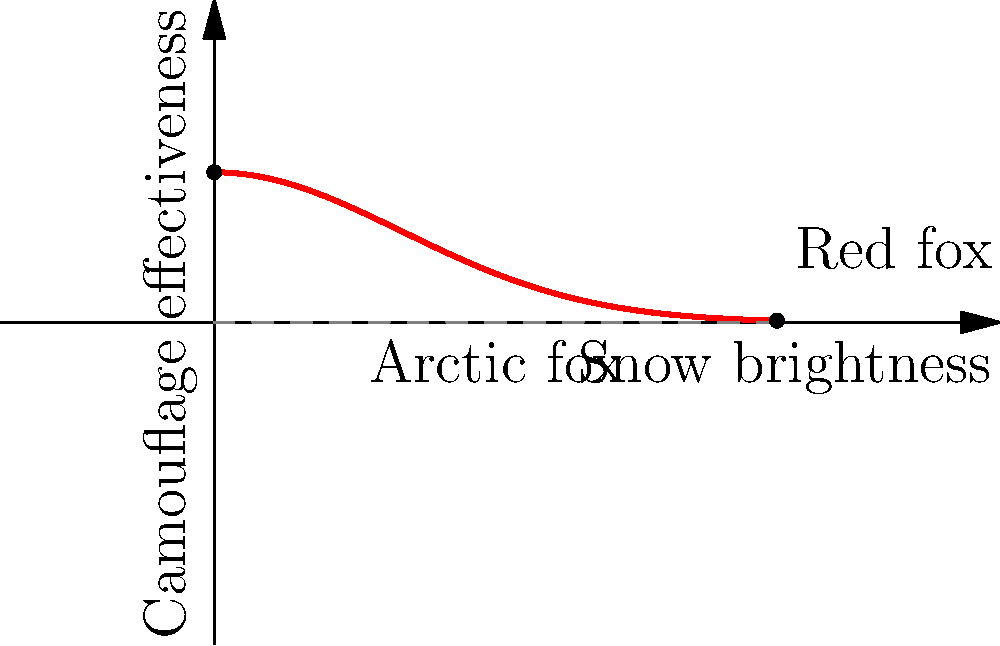Based on the graph showing the camouflage effectiveness of foxes in relation to snow brightness, which type of fox would be easier to spot in extremely bright snow conditions? To answer this question, we need to analyze the graph:

1. The x-axis represents snow brightness, increasing from left to right.
2. The y-axis represents camouflage effectiveness, increasing from bottom to top.
3. The curve shows how camouflage effectiveness changes with snow brightness.
4. At the left side of the graph (low snow brightness), we see "Arctic fox" labeled, indicating high camouflage effectiveness in less bright conditions.
5. At the right side of the graph (high snow brightness), we see "Red fox" labeled, indicating lower camouflage effectiveness in brighter conditions.
6. As snow brightness increases (moving right on the x-axis), the camouflage effectiveness decreases (the curve slopes downward).
7. In extremely bright snow conditions (far right of the x-axis), the camouflage effectiveness is at its lowest point on the curve.
8. This lowest point corresponds to the "Red fox" label, indicating that red foxes have the least effective camouflage in very bright snow.

Therefore, in extremely bright snow conditions, the red fox would be easier to spot due to its lower camouflage effectiveness.
Answer: Red fox 